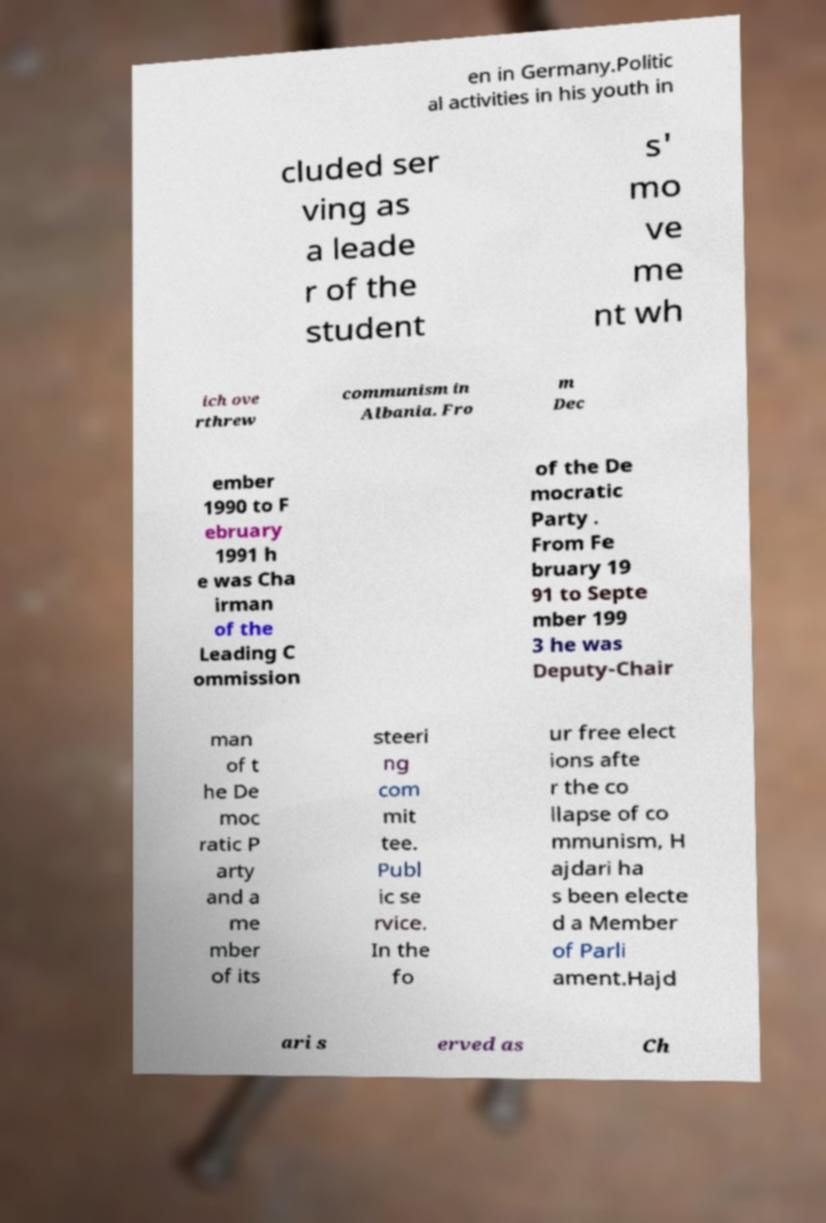Please identify and transcribe the text found in this image. en in Germany.Politic al activities in his youth in cluded ser ving as a leade r of the student s' mo ve me nt wh ich ove rthrew communism in Albania. Fro m Dec ember 1990 to F ebruary 1991 h e was Cha irman of the Leading C ommission of the De mocratic Party . From Fe bruary 19 91 to Septe mber 199 3 he was Deputy-Chair man of t he De moc ratic P arty and a me mber of its steeri ng com mit tee. Publ ic se rvice. In the fo ur free elect ions afte r the co llapse of co mmunism, H ajdari ha s been electe d a Member of Parli ament.Hajd ari s erved as Ch 